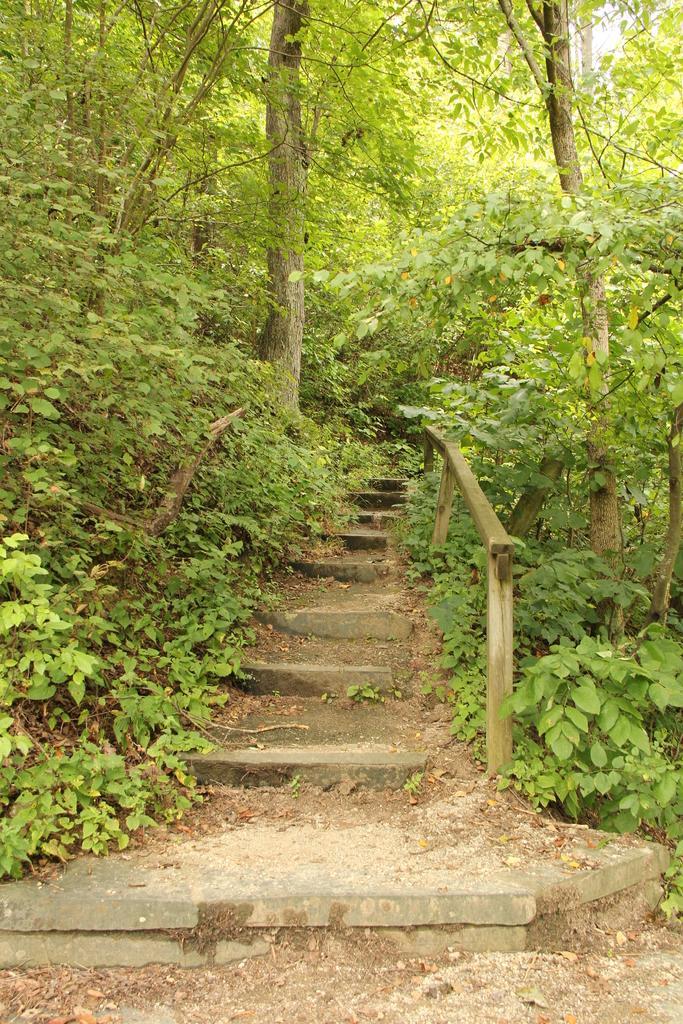Please provide a concise description of this image. In this image there are steps. Beside the steps there are plants on the ground. In the background there are trees. At the bottom there is the ground. 